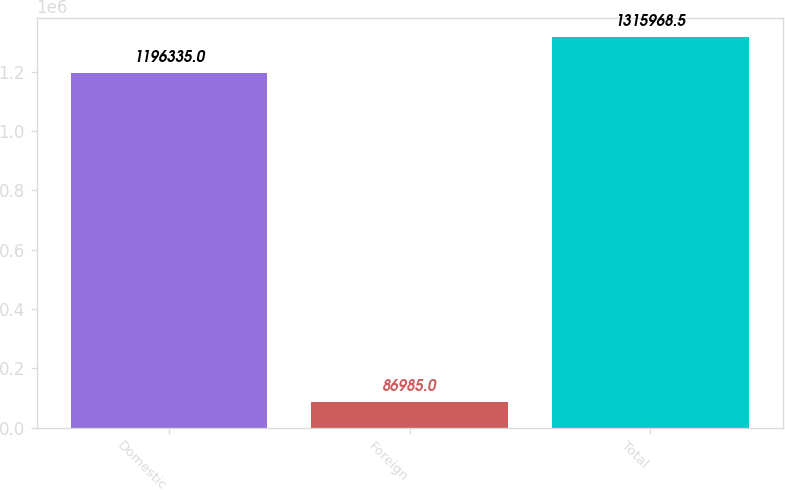Convert chart to OTSL. <chart><loc_0><loc_0><loc_500><loc_500><bar_chart><fcel>Domestic<fcel>Foreign<fcel>Total<nl><fcel>1.19634e+06<fcel>86985<fcel>1.31597e+06<nl></chart> 